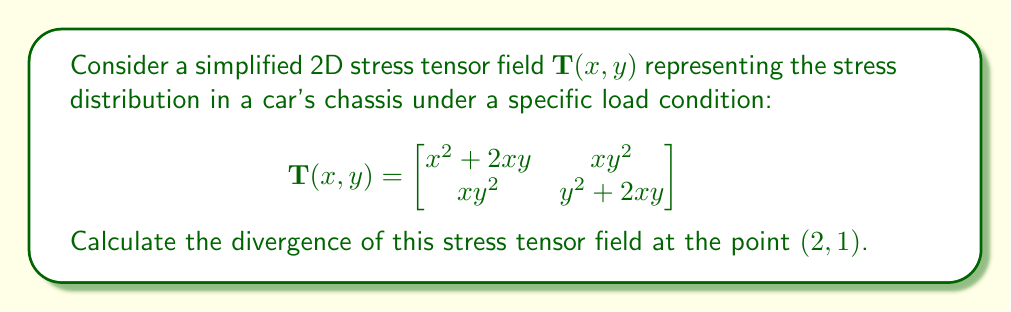Help me with this question. To solve this problem, we'll follow these steps:

1) The divergence of a 2D tensor field $\mathbf{T}(x,y)$ is defined as:

   $$\text{div}(\mathbf{T}) = \frac{\partial T_{xx}}{\partial x} + \frac{\partial T_{yy}}{\partial y}$$

2) From the given tensor:
   $T_{xx} = x^2 + 2xy$
   $T_{yy} = y^2 + 2xy$

3) Calculate $\frac{\partial T_{xx}}{\partial x}$:
   $$\frac{\partial T_{xx}}{\partial x} = \frac{\partial (x^2 + 2xy)}{\partial x} = 2x + 2y$$

4) Calculate $\frac{\partial T_{yy}}{\partial y}$:
   $$\frac{\partial T_{yy}}{\partial y} = \frac{\partial (y^2 + 2xy)}{\partial y} = 2y + 2x$$

5) Sum these partial derivatives:
   $$\text{div}(\mathbf{T}) = (2x + 2y) + (2y + 2x) = 4x + 4y$$

6) Evaluate at the point (2,1):
   $$\text{div}(\mathbf{T})(2,1) = 4(2) + 4(1) = 8 + 4 = 12$$

Therefore, the divergence of the stress tensor field at (2,1) is 12.
Answer: 12 